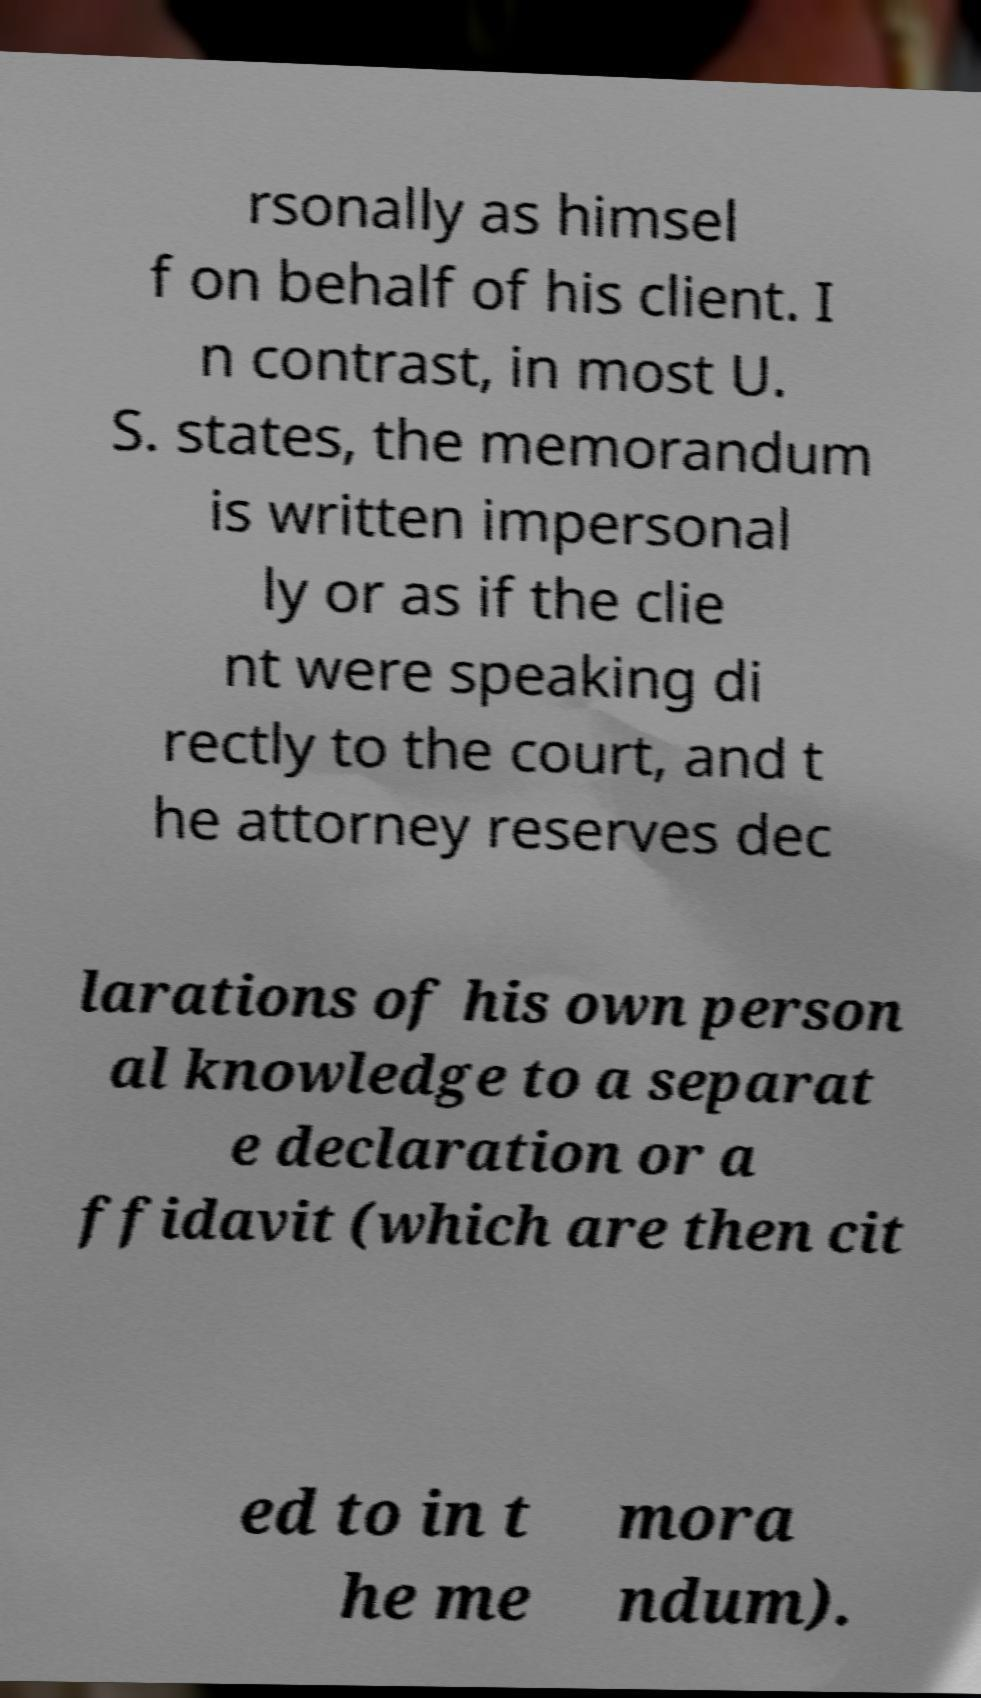Can you accurately transcribe the text from the provided image for me? rsonally as himsel f on behalf of his client. I n contrast, in most U. S. states, the memorandum is written impersonal ly or as if the clie nt were speaking di rectly to the court, and t he attorney reserves dec larations of his own person al knowledge to a separat e declaration or a ffidavit (which are then cit ed to in t he me mora ndum). 